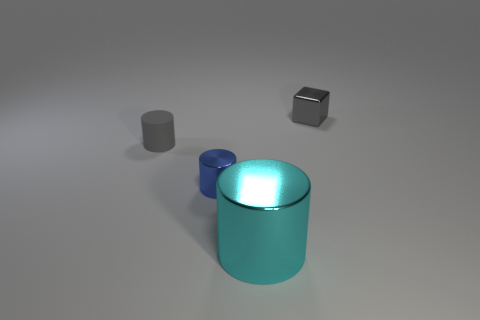Subtract all metal cylinders. How many cylinders are left? 1 Subtract all blue cylinders. How many cylinders are left? 2 Subtract all brown cylinders. How many blue blocks are left? 0 Add 2 large cyan shiny cylinders. How many objects exist? 6 Subtract all cylinders. How many objects are left? 1 Subtract all red cylinders. Subtract all gray spheres. How many cylinders are left? 3 Subtract all tiny blue shiny cylinders. Subtract all small metallic blocks. How many objects are left? 2 Add 2 tiny gray shiny cubes. How many tiny gray shiny cubes are left? 3 Add 1 large gray metallic balls. How many large gray metallic balls exist? 1 Subtract 0 red blocks. How many objects are left? 4 